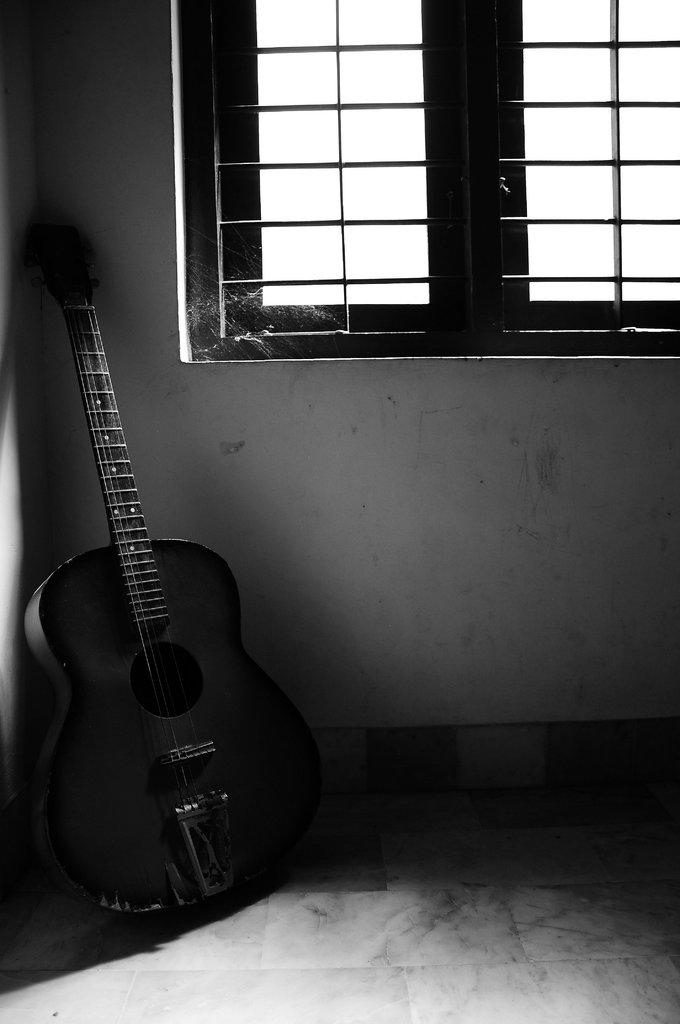What can be seen in the background of the image? There is a wall and windows in the background of the image. What object is placed on the floor in the image? There is a guitar placed on the floor in the image. Are there any birds visible in the image? There are no birds present in the image. Can you see a cobweb on the guitar in the image? There is no cobweb visible on the guitar in the image. 